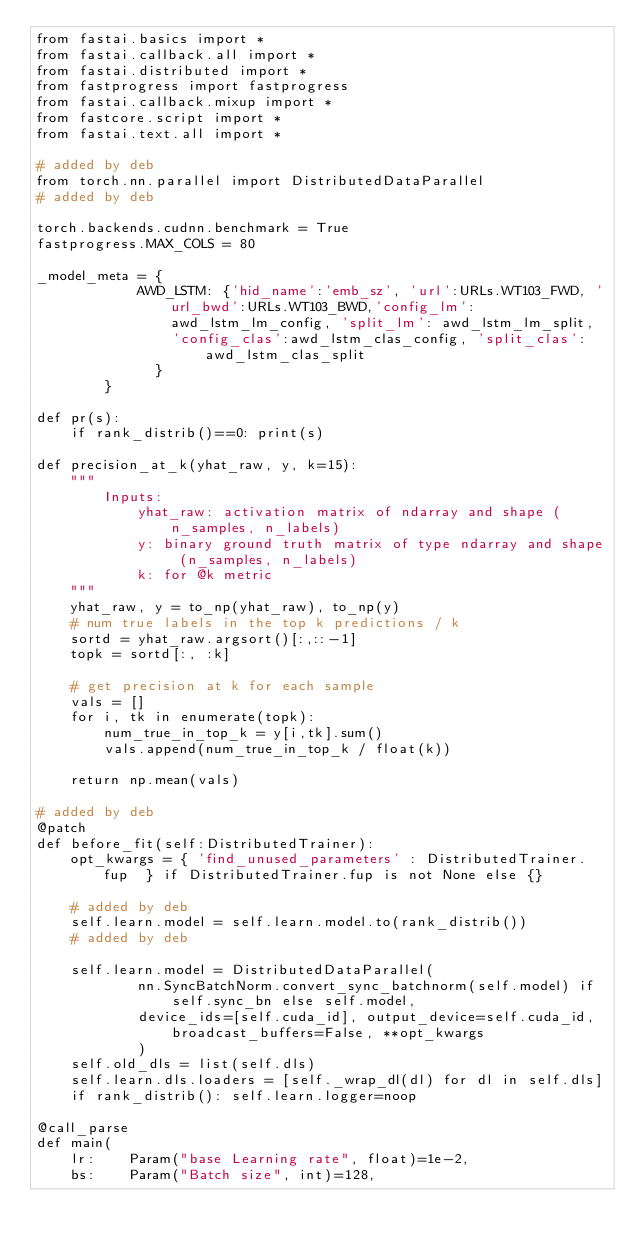<code> <loc_0><loc_0><loc_500><loc_500><_Python_>from fastai.basics import *
from fastai.callback.all import *
from fastai.distributed import *
from fastprogress import fastprogress
from fastai.callback.mixup import *
from fastcore.script import *
from fastai.text.all import *

# added by deb
from torch.nn.parallel import DistributedDataParallel
# added by deb

torch.backends.cudnn.benchmark = True
fastprogress.MAX_COLS = 80

_model_meta = {
            AWD_LSTM: {'hid_name':'emb_sz', 'url':URLs.WT103_FWD, 'url_bwd':URLs.WT103_BWD,'config_lm':awd_lstm_lm_config, 'split_lm': awd_lstm_lm_split,            
                'config_clas':awd_lstm_clas_config, 'split_clas': awd_lstm_clas_split
              }
        }

def pr(s):
    if rank_distrib()==0: print(s)

def precision_at_k(yhat_raw, y, k=15):
    """
        Inputs: 
            yhat_raw: activation matrix of ndarray and shape (n_samples, n_labels)
            y: binary ground truth matrix of type ndarray and shape (n_samples, n_labels)
            k: for @k metric
    """
    yhat_raw, y = to_np(yhat_raw), to_np(y)
    # num true labels in the top k predictions / k
    sortd = yhat_raw.argsort()[:,::-1]
    topk = sortd[:, :k]
    
    # get precision at k for each sample
    vals = []
    for i, tk in enumerate(topk):
        num_true_in_top_k = y[i,tk].sum()
        vals.append(num_true_in_top_k / float(k))
    
    return np.mean(vals)

# added by deb
@patch
def before_fit(self:DistributedTrainer):
    opt_kwargs = { 'find_unused_parameters' : DistributedTrainer.fup  } if DistributedTrainer.fup is not None else {}

    # added by deb
    self.learn.model = self.learn.model.to(rank_distrib())
    # added by deb
    
    self.learn.model = DistributedDataParallel(
            nn.SyncBatchNorm.convert_sync_batchnorm(self.model) if self.sync_bn else self.model,
            device_ids=[self.cuda_id], output_device=self.cuda_id, broadcast_buffers=False, **opt_kwargs
            )
    self.old_dls = list(self.dls)
    self.learn.dls.loaders = [self._wrap_dl(dl) for dl in self.dls]
    if rank_distrib(): self.learn.logger=noop

@call_parse
def main(
    lr:    Param("base Learning rate", float)=1e-2,
    bs:    Param("Batch size", int)=128,</code> 